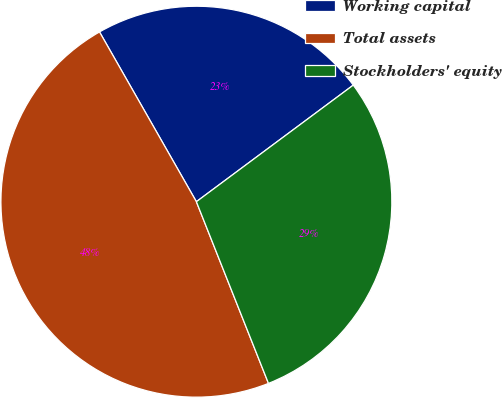Convert chart. <chart><loc_0><loc_0><loc_500><loc_500><pie_chart><fcel>Working capital<fcel>Total assets<fcel>Stockholders' equity<nl><fcel>23.08%<fcel>47.76%<fcel>29.16%<nl></chart> 